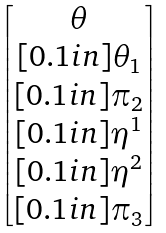Convert formula to latex. <formula><loc_0><loc_0><loc_500><loc_500>\begin{bmatrix} \theta \\ [ 0 . 1 i n ] \theta _ { 1 } \\ [ 0 . 1 i n ] \pi _ { 2 } \\ [ 0 . 1 i n ] \eta ^ { 1 } \\ [ 0 . 1 i n ] \eta ^ { 2 } \\ [ 0 . 1 i n ] \pi _ { 3 } \end{bmatrix}</formula> 